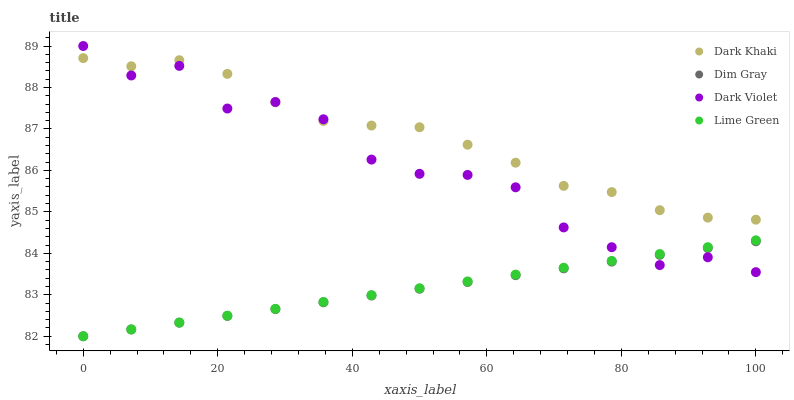Does Dim Gray have the minimum area under the curve?
Answer yes or no. Yes. Does Dark Khaki have the maximum area under the curve?
Answer yes or no. Yes. Does Lime Green have the minimum area under the curve?
Answer yes or no. No. Does Lime Green have the maximum area under the curve?
Answer yes or no. No. Is Dim Gray the smoothest?
Answer yes or no. Yes. Is Dark Violet the roughest?
Answer yes or no. Yes. Is Lime Green the smoothest?
Answer yes or no. No. Is Lime Green the roughest?
Answer yes or no. No. Does Dim Gray have the lowest value?
Answer yes or no. Yes. Does Dark Violet have the lowest value?
Answer yes or no. No. Does Dark Violet have the highest value?
Answer yes or no. Yes. Does Lime Green have the highest value?
Answer yes or no. No. Is Lime Green less than Dark Khaki?
Answer yes or no. Yes. Is Dark Khaki greater than Lime Green?
Answer yes or no. Yes. Does Dark Violet intersect Dim Gray?
Answer yes or no. Yes. Is Dark Violet less than Dim Gray?
Answer yes or no. No. Is Dark Violet greater than Dim Gray?
Answer yes or no. No. Does Lime Green intersect Dark Khaki?
Answer yes or no. No. 